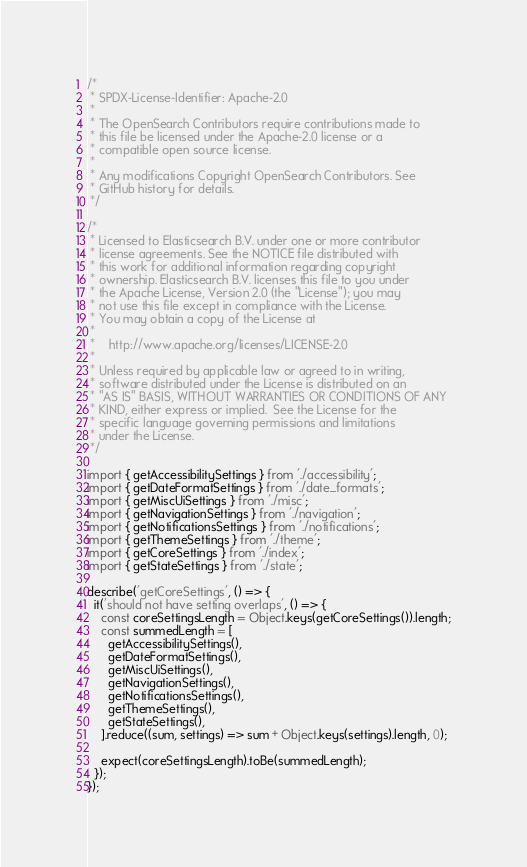<code> <loc_0><loc_0><loc_500><loc_500><_TypeScript_>/*
 * SPDX-License-Identifier: Apache-2.0
 *
 * The OpenSearch Contributors require contributions made to
 * this file be licensed under the Apache-2.0 license or a
 * compatible open source license.
 *
 * Any modifications Copyright OpenSearch Contributors. See
 * GitHub history for details.
 */

/*
 * Licensed to Elasticsearch B.V. under one or more contributor
 * license agreements. See the NOTICE file distributed with
 * this work for additional information regarding copyright
 * ownership. Elasticsearch B.V. licenses this file to you under
 * the Apache License, Version 2.0 (the "License"); you may
 * not use this file except in compliance with the License.
 * You may obtain a copy of the License at
 *
 *    http://www.apache.org/licenses/LICENSE-2.0
 *
 * Unless required by applicable law or agreed to in writing,
 * software distributed under the License is distributed on an
 * "AS IS" BASIS, WITHOUT WARRANTIES OR CONDITIONS OF ANY
 * KIND, either express or implied.  See the License for the
 * specific language governing permissions and limitations
 * under the License.
 */

import { getAccessibilitySettings } from './accessibility';
import { getDateFormatSettings } from './date_formats';
import { getMiscUiSettings } from './misc';
import { getNavigationSettings } from './navigation';
import { getNotificationsSettings } from './notifications';
import { getThemeSettings } from './theme';
import { getCoreSettings } from './index';
import { getStateSettings } from './state';

describe('getCoreSettings', () => {
  it('should not have setting overlaps', () => {
    const coreSettingsLength = Object.keys(getCoreSettings()).length;
    const summedLength = [
      getAccessibilitySettings(),
      getDateFormatSettings(),
      getMiscUiSettings(),
      getNavigationSettings(),
      getNotificationsSettings(),
      getThemeSettings(),
      getStateSettings(),
    ].reduce((sum, settings) => sum + Object.keys(settings).length, 0);

    expect(coreSettingsLength).toBe(summedLength);
  });
});
</code> 